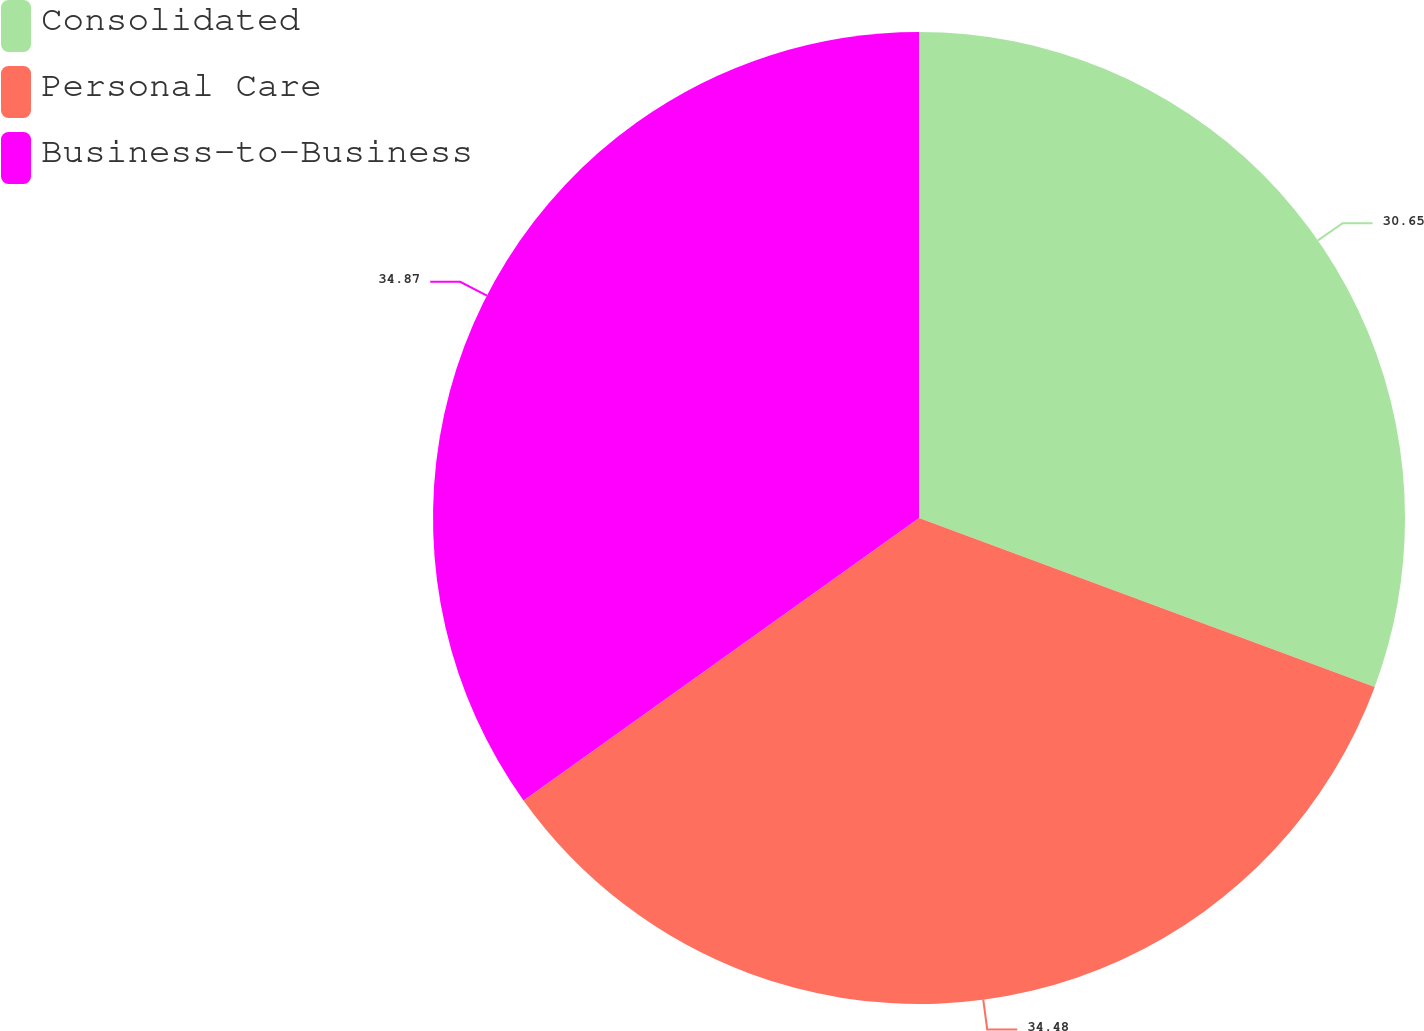<chart> <loc_0><loc_0><loc_500><loc_500><pie_chart><fcel>Consolidated<fcel>Personal Care<fcel>Business-to-Business<nl><fcel>30.65%<fcel>34.48%<fcel>34.87%<nl></chart> 